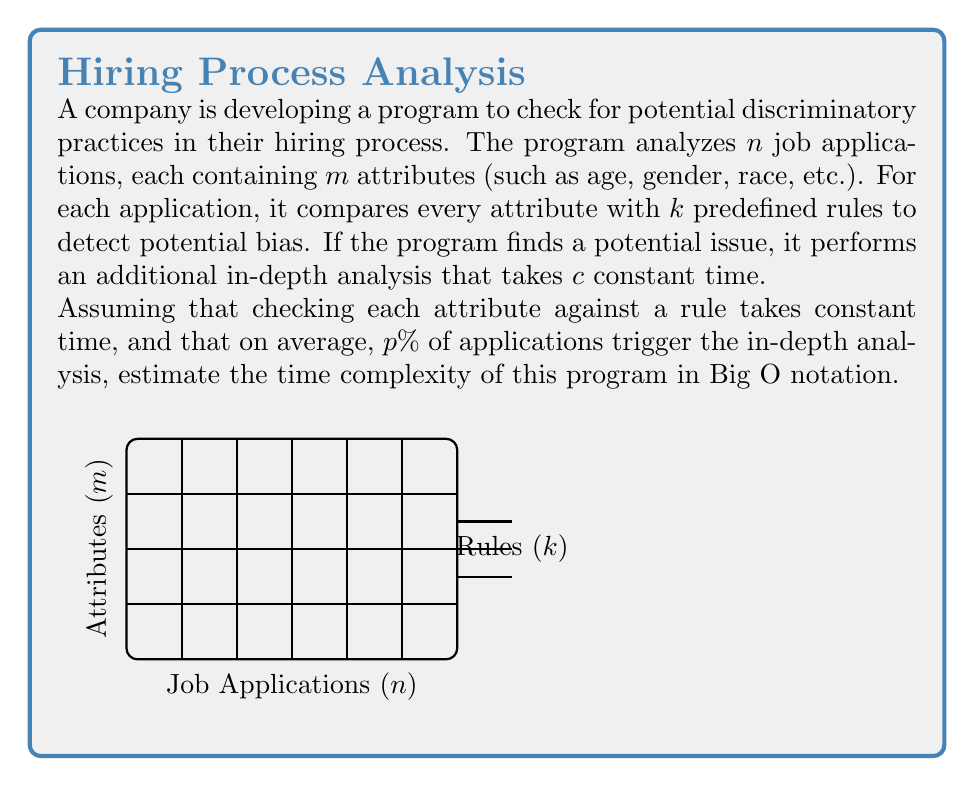What is the answer to this math problem? Let's break down the problem and analyze it step by step:

1) For each application, the program checks $m$ attributes against $k$ rules.
   - This results in $m \cdot k$ checks per application.
   - Since there are $n$ applications, the total number of checks is $n \cdot m \cdot k$.
   - Each check takes constant time, so this part has a time complexity of $O(nmk)$.

2) On average, $p\%$ of applications trigger the in-depth analysis.
   - This means $\frac{p}{100} \cdot n$ applications require additional processing.
   - Each in-depth analysis takes constant time $c$.
   - The time complexity for this part is $O(\frac{p}{100} \cdot n \cdot c) = O(n)$, as $p$ and $c$ are constants.

3) Combining these two parts:
   Total time complexity = $O(nmk) + O(n) = O(nmk + n)$

4) Since $m$ and $k$ are typically much larger than 1, we can simplify this to:
   $O(nmk)$

Therefore, the estimated time complexity of the program is $O(nmk)$.
Answer: $O(nmk)$ 